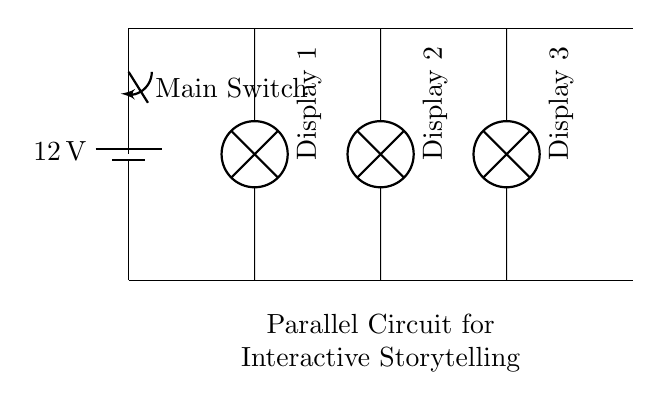What is the voltage of the circuit? The voltage is twelve volts, which is the voltage provided by the battery at the circuit's power source.
Answer: twelve volts How many digital displays are connected in parallel? There are three digital displays indicated in the circuit diagram, which shows three distinct lamp symbols for displays.
Answer: three What is the purpose of the switch in this circuit? The switch serves as a control to turn the entire circuit on or off, allowing for the operation or disconnection of all connected displays simultaneously.
Answer: control What type of circuit is illustrated in the diagram? The circuit is a parallel circuit because each display connects directly to the same voltage source and allows independent operation without influencing the other displays' performance.
Answer: parallel What happens to the other displays if one fails? If one display fails, the others will continue to operate normally because each is connected in parallel, meaning they are not dependent on each other for the circuit's functionality.
Answer: continue to operate 